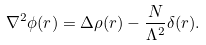Convert formula to latex. <formula><loc_0><loc_0><loc_500><loc_500>\nabla ^ { 2 } \phi ( r ) = \Delta \rho ( r ) - \frac { N } { \Lambda ^ { 2 } } \delta ( r ) .</formula> 